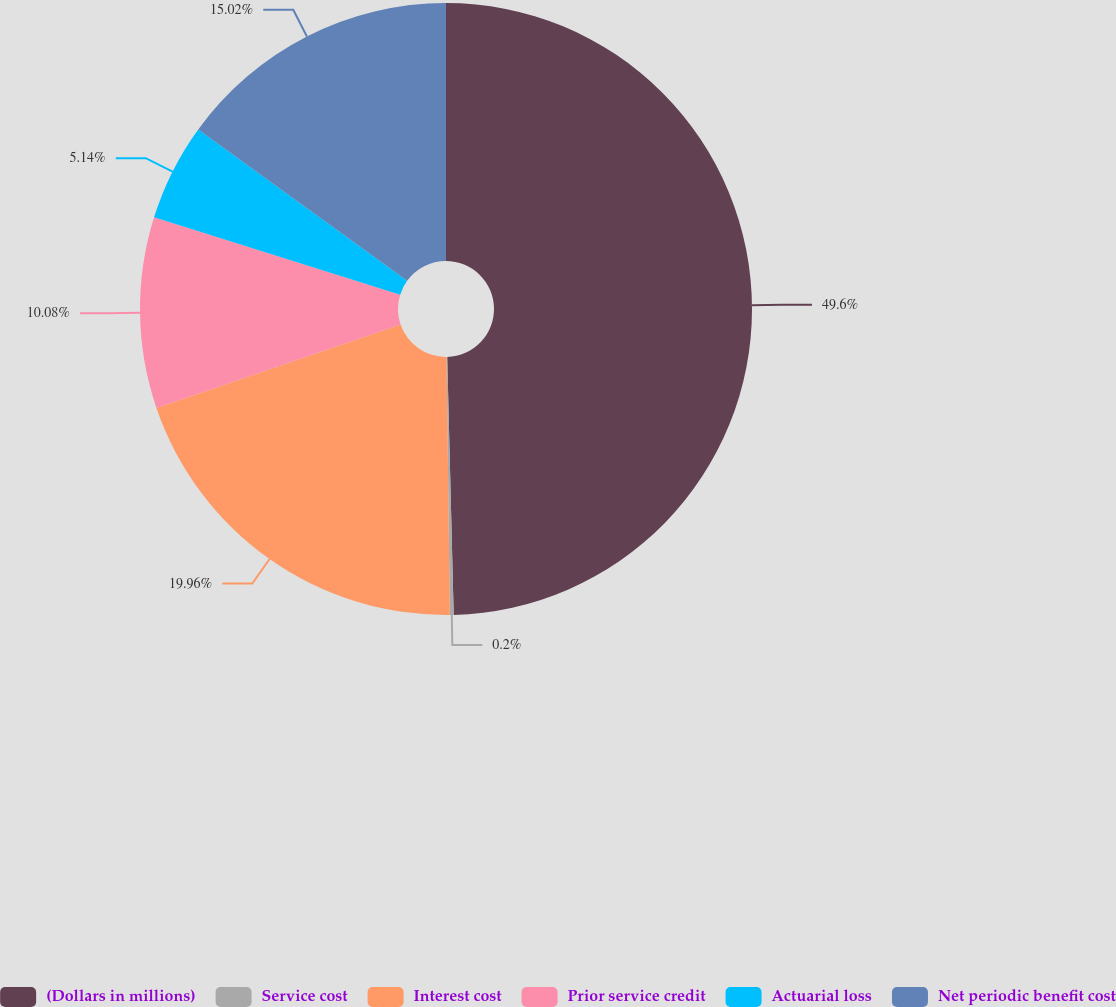<chart> <loc_0><loc_0><loc_500><loc_500><pie_chart><fcel>(Dollars in millions)<fcel>Service cost<fcel>Interest cost<fcel>Prior service credit<fcel>Actuarial loss<fcel>Net periodic benefit cost<nl><fcel>49.6%<fcel>0.2%<fcel>19.96%<fcel>10.08%<fcel>5.14%<fcel>15.02%<nl></chart> 